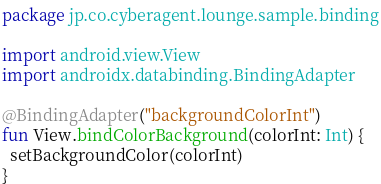Convert code to text. <code><loc_0><loc_0><loc_500><loc_500><_Kotlin_>package jp.co.cyberagent.lounge.sample.binding

import android.view.View
import androidx.databinding.BindingAdapter

@BindingAdapter("backgroundColorInt")
fun View.bindColorBackground(colorInt: Int) {
  setBackgroundColor(colorInt)
}
</code> 